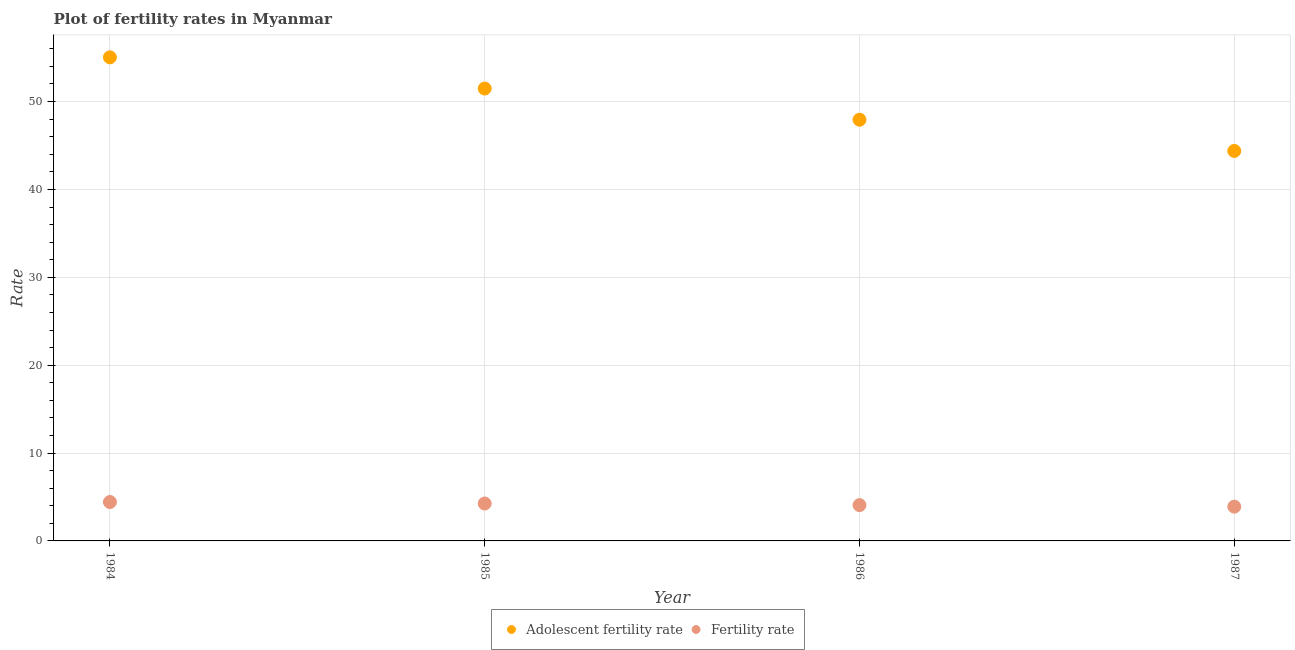How many different coloured dotlines are there?
Provide a succinct answer. 2. What is the adolescent fertility rate in 1986?
Your response must be concise. 47.93. Across all years, what is the maximum adolescent fertility rate?
Provide a short and direct response. 55.03. Across all years, what is the minimum adolescent fertility rate?
Ensure brevity in your answer.  44.38. In which year was the adolescent fertility rate maximum?
Offer a terse response. 1984. In which year was the adolescent fertility rate minimum?
Offer a very short reply. 1987. What is the total adolescent fertility rate in the graph?
Your response must be concise. 198.84. What is the difference between the adolescent fertility rate in 1984 and that in 1987?
Provide a succinct answer. 10.65. What is the difference between the adolescent fertility rate in 1986 and the fertility rate in 1984?
Make the answer very short. 43.51. What is the average adolescent fertility rate per year?
Offer a very short reply. 49.71. In the year 1986, what is the difference between the adolescent fertility rate and fertility rate?
Make the answer very short. 43.86. In how many years, is the adolescent fertility rate greater than 32?
Provide a short and direct response. 4. What is the ratio of the fertility rate in 1984 to that in 1986?
Provide a succinct answer. 1.09. Is the difference between the fertility rate in 1984 and 1986 greater than the difference between the adolescent fertility rate in 1984 and 1986?
Give a very brief answer. No. What is the difference between the highest and the second highest adolescent fertility rate?
Keep it short and to the point. 3.55. What is the difference between the highest and the lowest fertility rate?
Provide a short and direct response. 0.53. In how many years, is the fertility rate greater than the average fertility rate taken over all years?
Keep it short and to the point. 2. What is the difference between two consecutive major ticks on the Y-axis?
Keep it short and to the point. 10. Are the values on the major ticks of Y-axis written in scientific E-notation?
Ensure brevity in your answer.  No. Does the graph contain grids?
Your answer should be very brief. Yes. How many legend labels are there?
Your answer should be compact. 2. What is the title of the graph?
Offer a very short reply. Plot of fertility rates in Myanmar. What is the label or title of the X-axis?
Your answer should be very brief. Year. What is the label or title of the Y-axis?
Your response must be concise. Rate. What is the Rate in Adolescent fertility rate in 1984?
Keep it short and to the point. 55.03. What is the Rate of Fertility rate in 1984?
Give a very brief answer. 4.43. What is the Rate in Adolescent fertility rate in 1985?
Your answer should be very brief. 51.48. What is the Rate in Fertility rate in 1985?
Ensure brevity in your answer.  4.26. What is the Rate in Adolescent fertility rate in 1986?
Provide a succinct answer. 47.93. What is the Rate of Fertility rate in 1986?
Make the answer very short. 4.08. What is the Rate in Adolescent fertility rate in 1987?
Your answer should be compact. 44.38. What is the Rate in Fertility rate in 1987?
Your response must be concise. 3.9. Across all years, what is the maximum Rate in Adolescent fertility rate?
Offer a very short reply. 55.03. Across all years, what is the maximum Rate in Fertility rate?
Your answer should be very brief. 4.43. Across all years, what is the minimum Rate in Adolescent fertility rate?
Offer a terse response. 44.38. Across all years, what is the minimum Rate of Fertility rate?
Offer a terse response. 3.9. What is the total Rate of Adolescent fertility rate in the graph?
Give a very brief answer. 198.84. What is the total Rate of Fertility rate in the graph?
Give a very brief answer. 16.66. What is the difference between the Rate in Adolescent fertility rate in 1984 and that in 1985?
Your answer should be compact. 3.55. What is the difference between the Rate in Fertility rate in 1984 and that in 1985?
Offer a terse response. 0.17. What is the difference between the Rate in Fertility rate in 1984 and that in 1986?
Provide a short and direct response. 0.35. What is the difference between the Rate in Adolescent fertility rate in 1984 and that in 1987?
Offer a terse response. 10.65. What is the difference between the Rate of Fertility rate in 1984 and that in 1987?
Your answer should be compact. 0.53. What is the difference between the Rate of Adolescent fertility rate in 1985 and that in 1986?
Provide a short and direct response. 3.55. What is the difference between the Rate of Fertility rate in 1985 and that in 1986?
Provide a short and direct response. 0.18. What is the difference between the Rate of Adolescent fertility rate in 1985 and that in 1987?
Keep it short and to the point. 7.1. What is the difference between the Rate in Fertility rate in 1985 and that in 1987?
Keep it short and to the point. 0.35. What is the difference between the Rate of Adolescent fertility rate in 1986 and that in 1987?
Offer a terse response. 3.55. What is the difference between the Rate of Fertility rate in 1986 and that in 1987?
Offer a very short reply. 0.18. What is the difference between the Rate of Adolescent fertility rate in 1984 and the Rate of Fertility rate in 1985?
Your answer should be compact. 50.78. What is the difference between the Rate in Adolescent fertility rate in 1984 and the Rate in Fertility rate in 1986?
Give a very brief answer. 50.96. What is the difference between the Rate of Adolescent fertility rate in 1984 and the Rate of Fertility rate in 1987?
Make the answer very short. 51.13. What is the difference between the Rate in Adolescent fertility rate in 1985 and the Rate in Fertility rate in 1986?
Give a very brief answer. 47.41. What is the difference between the Rate of Adolescent fertility rate in 1985 and the Rate of Fertility rate in 1987?
Provide a succinct answer. 47.58. What is the difference between the Rate in Adolescent fertility rate in 1986 and the Rate in Fertility rate in 1987?
Offer a terse response. 44.03. What is the average Rate in Adolescent fertility rate per year?
Keep it short and to the point. 49.71. What is the average Rate of Fertility rate per year?
Provide a succinct answer. 4.17. In the year 1984, what is the difference between the Rate in Adolescent fertility rate and Rate in Fertility rate?
Your answer should be compact. 50.6. In the year 1985, what is the difference between the Rate of Adolescent fertility rate and Rate of Fertility rate?
Make the answer very short. 47.23. In the year 1986, what is the difference between the Rate in Adolescent fertility rate and Rate in Fertility rate?
Make the answer very short. 43.86. In the year 1987, what is the difference between the Rate in Adolescent fertility rate and Rate in Fertility rate?
Your answer should be compact. 40.48. What is the ratio of the Rate in Adolescent fertility rate in 1984 to that in 1985?
Offer a terse response. 1.07. What is the ratio of the Rate of Fertility rate in 1984 to that in 1985?
Offer a very short reply. 1.04. What is the ratio of the Rate of Adolescent fertility rate in 1984 to that in 1986?
Provide a succinct answer. 1.15. What is the ratio of the Rate in Fertility rate in 1984 to that in 1986?
Your answer should be very brief. 1.09. What is the ratio of the Rate of Adolescent fertility rate in 1984 to that in 1987?
Make the answer very short. 1.24. What is the ratio of the Rate in Fertility rate in 1984 to that in 1987?
Your answer should be compact. 1.14. What is the ratio of the Rate of Adolescent fertility rate in 1985 to that in 1986?
Your answer should be compact. 1.07. What is the ratio of the Rate in Fertility rate in 1985 to that in 1986?
Give a very brief answer. 1.04. What is the ratio of the Rate in Adolescent fertility rate in 1985 to that in 1987?
Provide a succinct answer. 1.16. What is the ratio of the Rate of Fertility rate in 1985 to that in 1987?
Provide a succinct answer. 1.09. What is the ratio of the Rate in Adolescent fertility rate in 1986 to that in 1987?
Your answer should be very brief. 1.08. What is the ratio of the Rate of Fertility rate in 1986 to that in 1987?
Your response must be concise. 1.05. What is the difference between the highest and the second highest Rate of Adolescent fertility rate?
Provide a short and direct response. 3.55. What is the difference between the highest and the second highest Rate of Fertility rate?
Your answer should be very brief. 0.17. What is the difference between the highest and the lowest Rate of Adolescent fertility rate?
Give a very brief answer. 10.65. What is the difference between the highest and the lowest Rate of Fertility rate?
Your answer should be very brief. 0.53. 